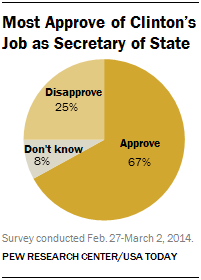What's the color of largest segment?
 Orange 